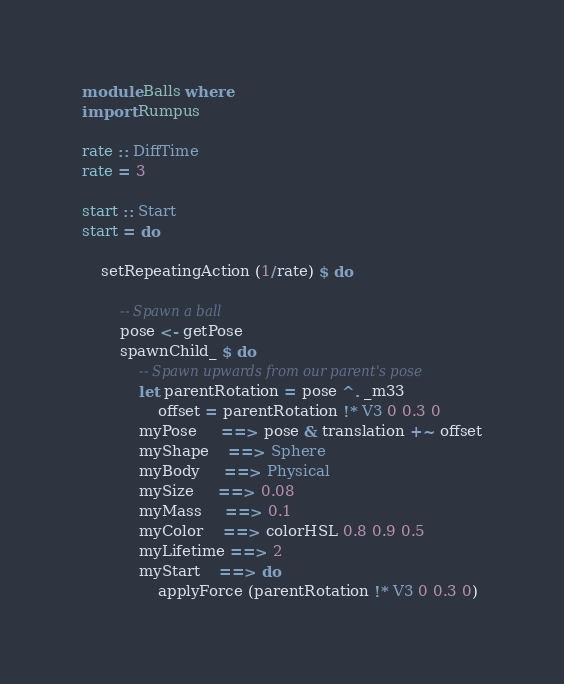Convert code to text. <code><loc_0><loc_0><loc_500><loc_500><_Haskell_>module Balls where
import Rumpus

rate :: DiffTime
rate = 3

start :: Start
start = do

    setRepeatingAction (1/rate) $ do

        -- Spawn a ball
        pose <- getPose
        spawnChild_ $ do
            -- Spawn upwards from our parent's pose
            let parentRotation = pose ^. _m33
                offset = parentRotation !* V3 0 0.3 0
            myPose     ==> pose & translation +~ offset
            myShape    ==> Sphere
            myBody     ==> Physical
            mySize     ==> 0.08
            myMass     ==> 0.1
            myColor    ==> colorHSL 0.8 0.9 0.5
            myLifetime ==> 2
            myStart    ==> do
                applyForce (parentRotation !* V3 0 0.3 0)</code> 